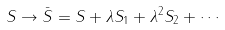Convert formula to latex. <formula><loc_0><loc_0><loc_500><loc_500>S \rightarrow \bar { S } = S + \lambda S _ { 1 } + \lambda ^ { 2 } S _ { 2 } + \cdots</formula> 